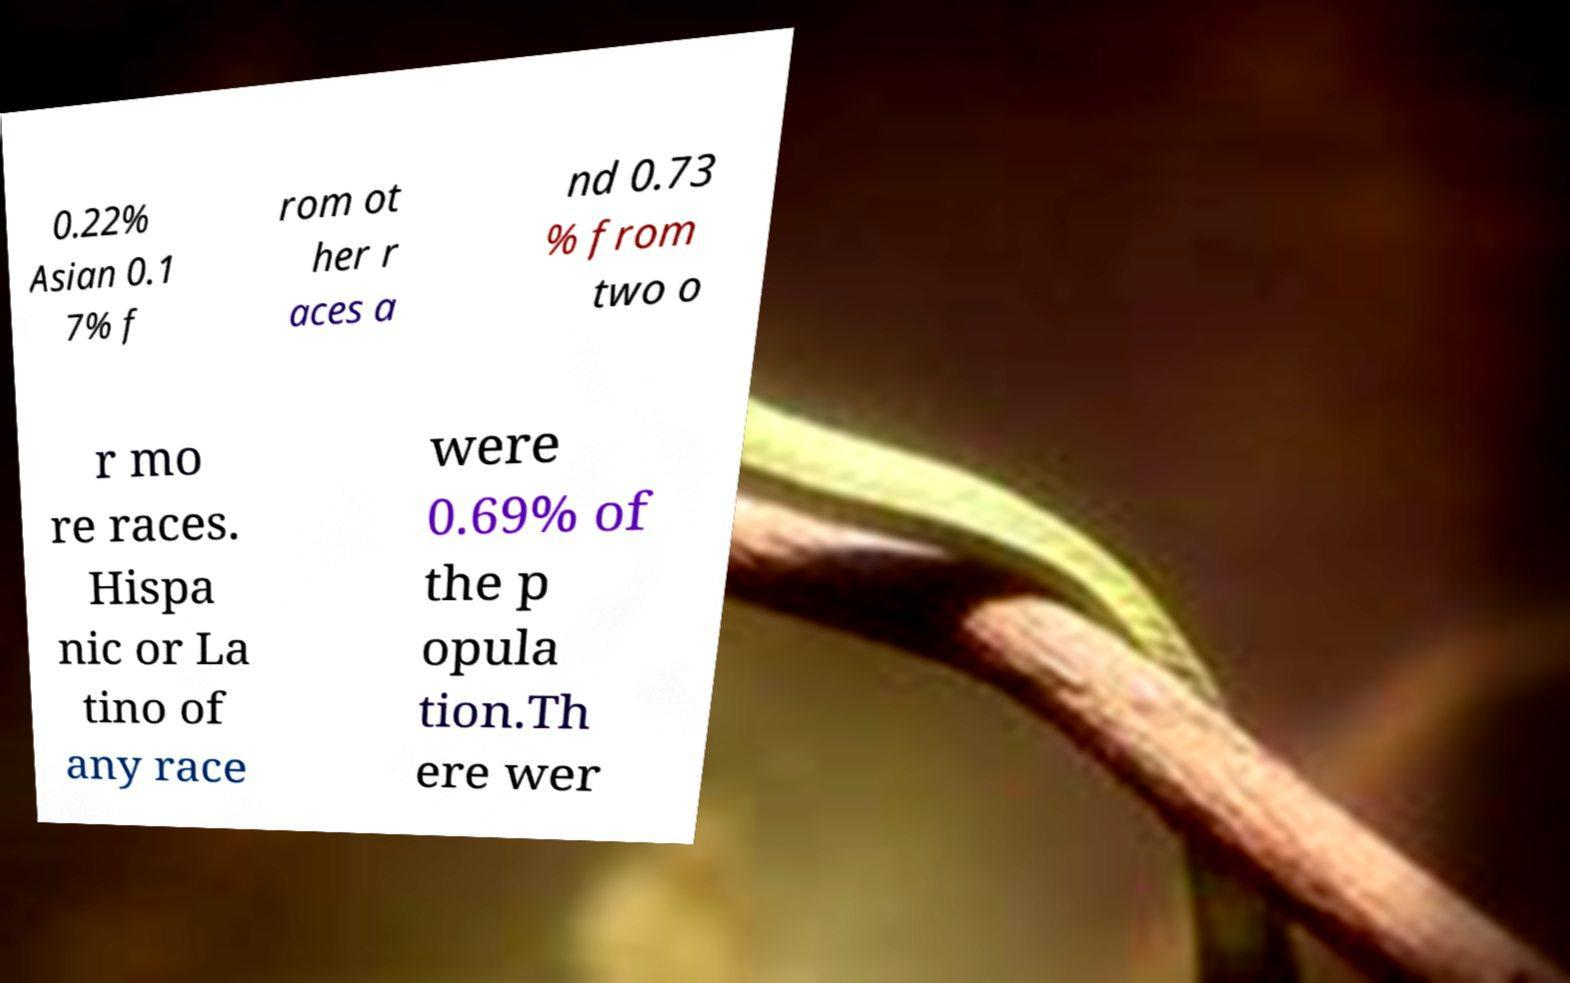I need the written content from this picture converted into text. Can you do that? 0.22% Asian 0.1 7% f rom ot her r aces a nd 0.73 % from two o r mo re races. Hispa nic or La tino of any race were 0.69% of the p opula tion.Th ere wer 